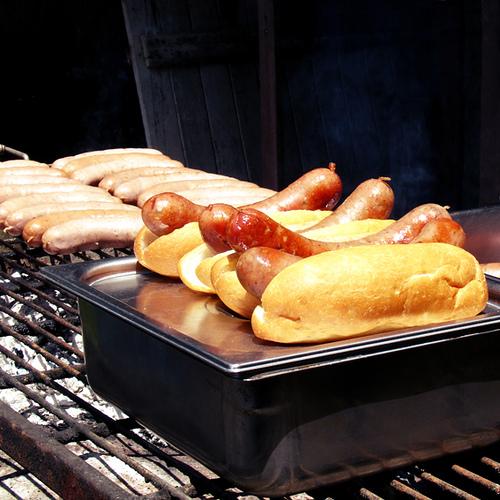How many hot dogs in total?
Be succinct. 20. What is the hot dogs in?
Short answer required. Buns. How many hot dogs are ready to eat?
Keep it brief. 4. 